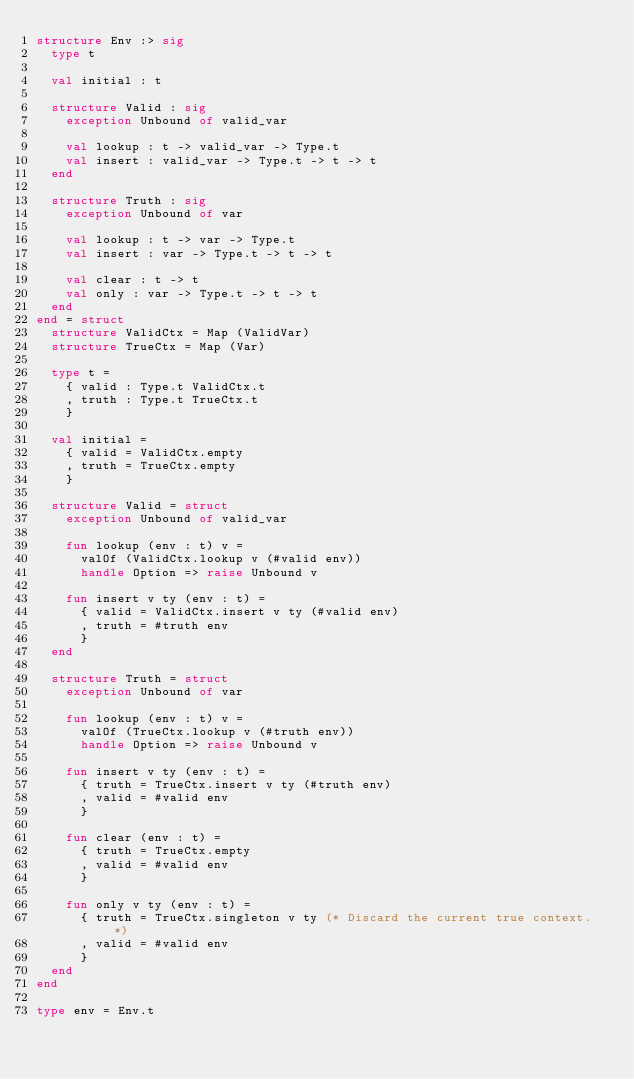Convert code to text. <code><loc_0><loc_0><loc_500><loc_500><_SML_>structure Env :> sig
  type t

  val initial : t

  structure Valid : sig
    exception Unbound of valid_var

    val lookup : t -> valid_var -> Type.t
    val insert : valid_var -> Type.t -> t -> t
  end

  structure Truth : sig
    exception Unbound of var

    val lookup : t -> var -> Type.t
    val insert : var -> Type.t -> t -> t

    val clear : t -> t
    val only : var -> Type.t -> t -> t
  end
end = struct
  structure ValidCtx = Map (ValidVar)
  structure TrueCtx = Map (Var)

  type t =
    { valid : Type.t ValidCtx.t
    , truth : Type.t TrueCtx.t
    }

  val initial =
    { valid = ValidCtx.empty
    , truth = TrueCtx.empty
    }

  structure Valid = struct
    exception Unbound of valid_var

    fun lookup (env : t) v =
      valOf (ValidCtx.lookup v (#valid env))
      handle Option => raise Unbound v

    fun insert v ty (env : t) =
      { valid = ValidCtx.insert v ty (#valid env)
      , truth = #truth env
      }
  end

  structure Truth = struct
    exception Unbound of var

    fun lookup (env : t) v =
      valOf (TrueCtx.lookup v (#truth env))
      handle Option => raise Unbound v

    fun insert v ty (env : t) =
      { truth = TrueCtx.insert v ty (#truth env)
      , valid = #valid env
      }

    fun clear (env : t) =
      { truth = TrueCtx.empty
      , valid = #valid env
      }

    fun only v ty (env : t) =
      { truth = TrueCtx.singleton v ty (* Discard the current true context. *)
      , valid = #valid env
      }
  end
end

type env = Env.t
</code> 